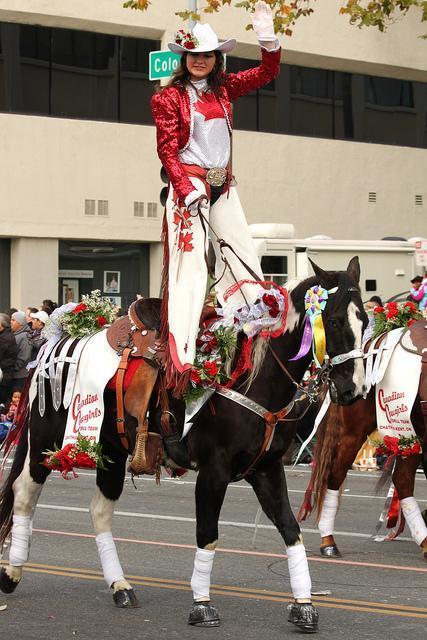How many horses are there?
Give a very brief answer. 2. How many boats r in the water?
Give a very brief answer. 0. 